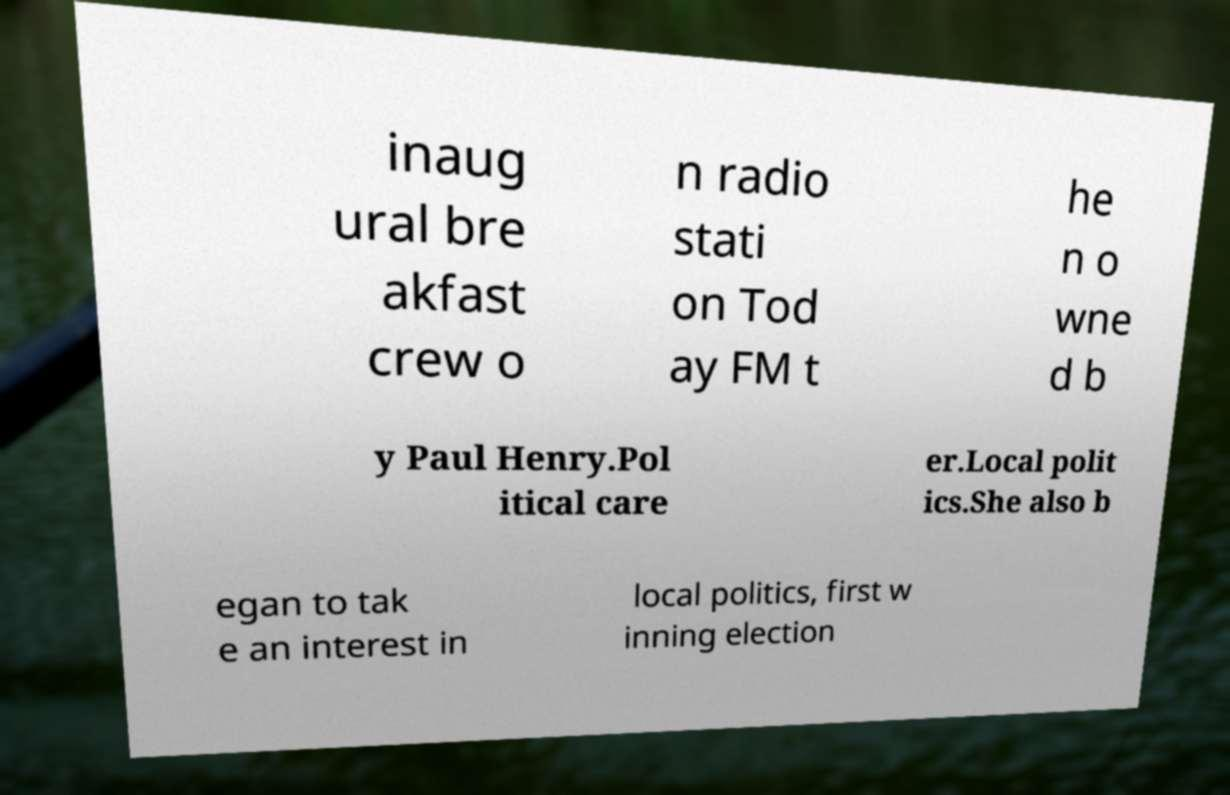There's text embedded in this image that I need extracted. Can you transcribe it verbatim? inaug ural bre akfast crew o n radio stati on Tod ay FM t he n o wne d b y Paul Henry.Pol itical care er.Local polit ics.She also b egan to tak e an interest in local politics, first w inning election 